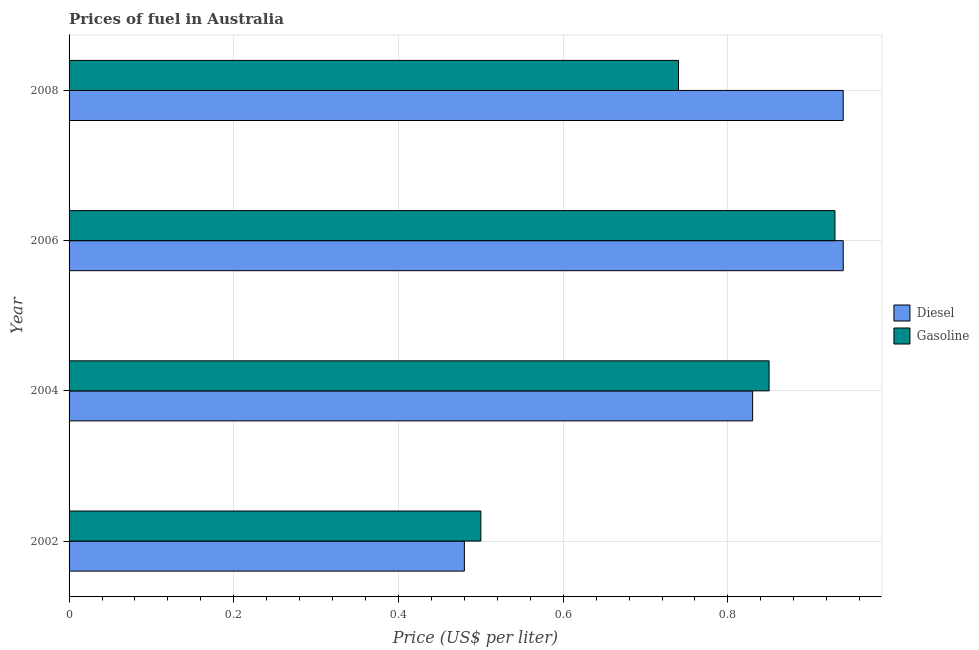How many groups of bars are there?
Your response must be concise. 4. Are the number of bars per tick equal to the number of legend labels?
Offer a very short reply. Yes. Are the number of bars on each tick of the Y-axis equal?
Your answer should be very brief. Yes. How many bars are there on the 1st tick from the top?
Offer a very short reply. 2. What is the label of the 3rd group of bars from the top?
Provide a short and direct response. 2004. What is the gasoline price in 2008?
Keep it short and to the point. 0.74. Across all years, what is the minimum diesel price?
Give a very brief answer. 0.48. In which year was the gasoline price maximum?
Ensure brevity in your answer.  2006. What is the total diesel price in the graph?
Ensure brevity in your answer.  3.19. What is the difference between the gasoline price in 2006 and that in 2008?
Keep it short and to the point. 0.19. What is the difference between the diesel price in 2002 and the gasoline price in 2004?
Your response must be concise. -0.37. What is the average diesel price per year?
Your answer should be very brief. 0.8. In the year 2006, what is the difference between the gasoline price and diesel price?
Provide a short and direct response. -0.01. In how many years, is the diesel price greater than 0.36 US$ per litre?
Your response must be concise. 4. What is the ratio of the gasoline price in 2002 to that in 2008?
Give a very brief answer. 0.68. What is the difference between the highest and the second highest gasoline price?
Give a very brief answer. 0.08. What is the difference between the highest and the lowest diesel price?
Give a very brief answer. 0.46. Is the sum of the diesel price in 2002 and 2008 greater than the maximum gasoline price across all years?
Offer a very short reply. Yes. What does the 2nd bar from the top in 2002 represents?
Your answer should be very brief. Diesel. What does the 1st bar from the bottom in 2008 represents?
Keep it short and to the point. Diesel. What is the difference between two consecutive major ticks on the X-axis?
Your response must be concise. 0.2. Does the graph contain grids?
Provide a short and direct response. Yes. Where does the legend appear in the graph?
Your answer should be compact. Center right. What is the title of the graph?
Your response must be concise. Prices of fuel in Australia. What is the label or title of the X-axis?
Your answer should be compact. Price (US$ per liter). What is the Price (US$ per liter) in Diesel in 2002?
Your answer should be very brief. 0.48. What is the Price (US$ per liter) in Diesel in 2004?
Keep it short and to the point. 0.83. What is the Price (US$ per liter) of Diesel in 2008?
Keep it short and to the point. 0.94. What is the Price (US$ per liter) of Gasoline in 2008?
Your answer should be very brief. 0.74. Across all years, what is the maximum Price (US$ per liter) of Diesel?
Provide a succinct answer. 0.94. Across all years, what is the minimum Price (US$ per liter) in Diesel?
Ensure brevity in your answer.  0.48. What is the total Price (US$ per liter) in Diesel in the graph?
Your answer should be very brief. 3.19. What is the total Price (US$ per liter) in Gasoline in the graph?
Ensure brevity in your answer.  3.02. What is the difference between the Price (US$ per liter) of Diesel in 2002 and that in 2004?
Your answer should be very brief. -0.35. What is the difference between the Price (US$ per liter) in Gasoline in 2002 and that in 2004?
Give a very brief answer. -0.35. What is the difference between the Price (US$ per liter) in Diesel in 2002 and that in 2006?
Your answer should be very brief. -0.46. What is the difference between the Price (US$ per liter) of Gasoline in 2002 and that in 2006?
Offer a very short reply. -0.43. What is the difference between the Price (US$ per liter) of Diesel in 2002 and that in 2008?
Offer a very short reply. -0.46. What is the difference between the Price (US$ per liter) of Gasoline in 2002 and that in 2008?
Your response must be concise. -0.24. What is the difference between the Price (US$ per liter) of Diesel in 2004 and that in 2006?
Your response must be concise. -0.11. What is the difference between the Price (US$ per liter) in Gasoline in 2004 and that in 2006?
Give a very brief answer. -0.08. What is the difference between the Price (US$ per liter) in Diesel in 2004 and that in 2008?
Ensure brevity in your answer.  -0.11. What is the difference between the Price (US$ per liter) in Gasoline in 2004 and that in 2008?
Offer a terse response. 0.11. What is the difference between the Price (US$ per liter) in Gasoline in 2006 and that in 2008?
Keep it short and to the point. 0.19. What is the difference between the Price (US$ per liter) in Diesel in 2002 and the Price (US$ per liter) in Gasoline in 2004?
Keep it short and to the point. -0.37. What is the difference between the Price (US$ per liter) of Diesel in 2002 and the Price (US$ per liter) of Gasoline in 2006?
Your answer should be compact. -0.45. What is the difference between the Price (US$ per liter) in Diesel in 2002 and the Price (US$ per liter) in Gasoline in 2008?
Give a very brief answer. -0.26. What is the difference between the Price (US$ per liter) of Diesel in 2004 and the Price (US$ per liter) of Gasoline in 2008?
Offer a terse response. 0.09. What is the average Price (US$ per liter) of Diesel per year?
Offer a terse response. 0.8. What is the average Price (US$ per liter) in Gasoline per year?
Provide a succinct answer. 0.76. In the year 2002, what is the difference between the Price (US$ per liter) in Diesel and Price (US$ per liter) in Gasoline?
Keep it short and to the point. -0.02. In the year 2004, what is the difference between the Price (US$ per liter) in Diesel and Price (US$ per liter) in Gasoline?
Make the answer very short. -0.02. In the year 2008, what is the difference between the Price (US$ per liter) of Diesel and Price (US$ per liter) of Gasoline?
Offer a terse response. 0.2. What is the ratio of the Price (US$ per liter) of Diesel in 2002 to that in 2004?
Ensure brevity in your answer.  0.58. What is the ratio of the Price (US$ per liter) of Gasoline in 2002 to that in 2004?
Provide a short and direct response. 0.59. What is the ratio of the Price (US$ per liter) of Diesel in 2002 to that in 2006?
Your response must be concise. 0.51. What is the ratio of the Price (US$ per liter) of Gasoline in 2002 to that in 2006?
Offer a very short reply. 0.54. What is the ratio of the Price (US$ per liter) in Diesel in 2002 to that in 2008?
Provide a short and direct response. 0.51. What is the ratio of the Price (US$ per liter) in Gasoline in 2002 to that in 2008?
Offer a very short reply. 0.68. What is the ratio of the Price (US$ per liter) in Diesel in 2004 to that in 2006?
Offer a terse response. 0.88. What is the ratio of the Price (US$ per liter) in Gasoline in 2004 to that in 2006?
Offer a terse response. 0.91. What is the ratio of the Price (US$ per liter) in Diesel in 2004 to that in 2008?
Your answer should be compact. 0.88. What is the ratio of the Price (US$ per liter) of Gasoline in 2004 to that in 2008?
Provide a short and direct response. 1.15. What is the ratio of the Price (US$ per liter) of Diesel in 2006 to that in 2008?
Give a very brief answer. 1. What is the ratio of the Price (US$ per liter) in Gasoline in 2006 to that in 2008?
Offer a terse response. 1.26. What is the difference between the highest and the second highest Price (US$ per liter) of Diesel?
Your answer should be very brief. 0. What is the difference between the highest and the lowest Price (US$ per liter) of Diesel?
Provide a short and direct response. 0.46. What is the difference between the highest and the lowest Price (US$ per liter) of Gasoline?
Offer a very short reply. 0.43. 